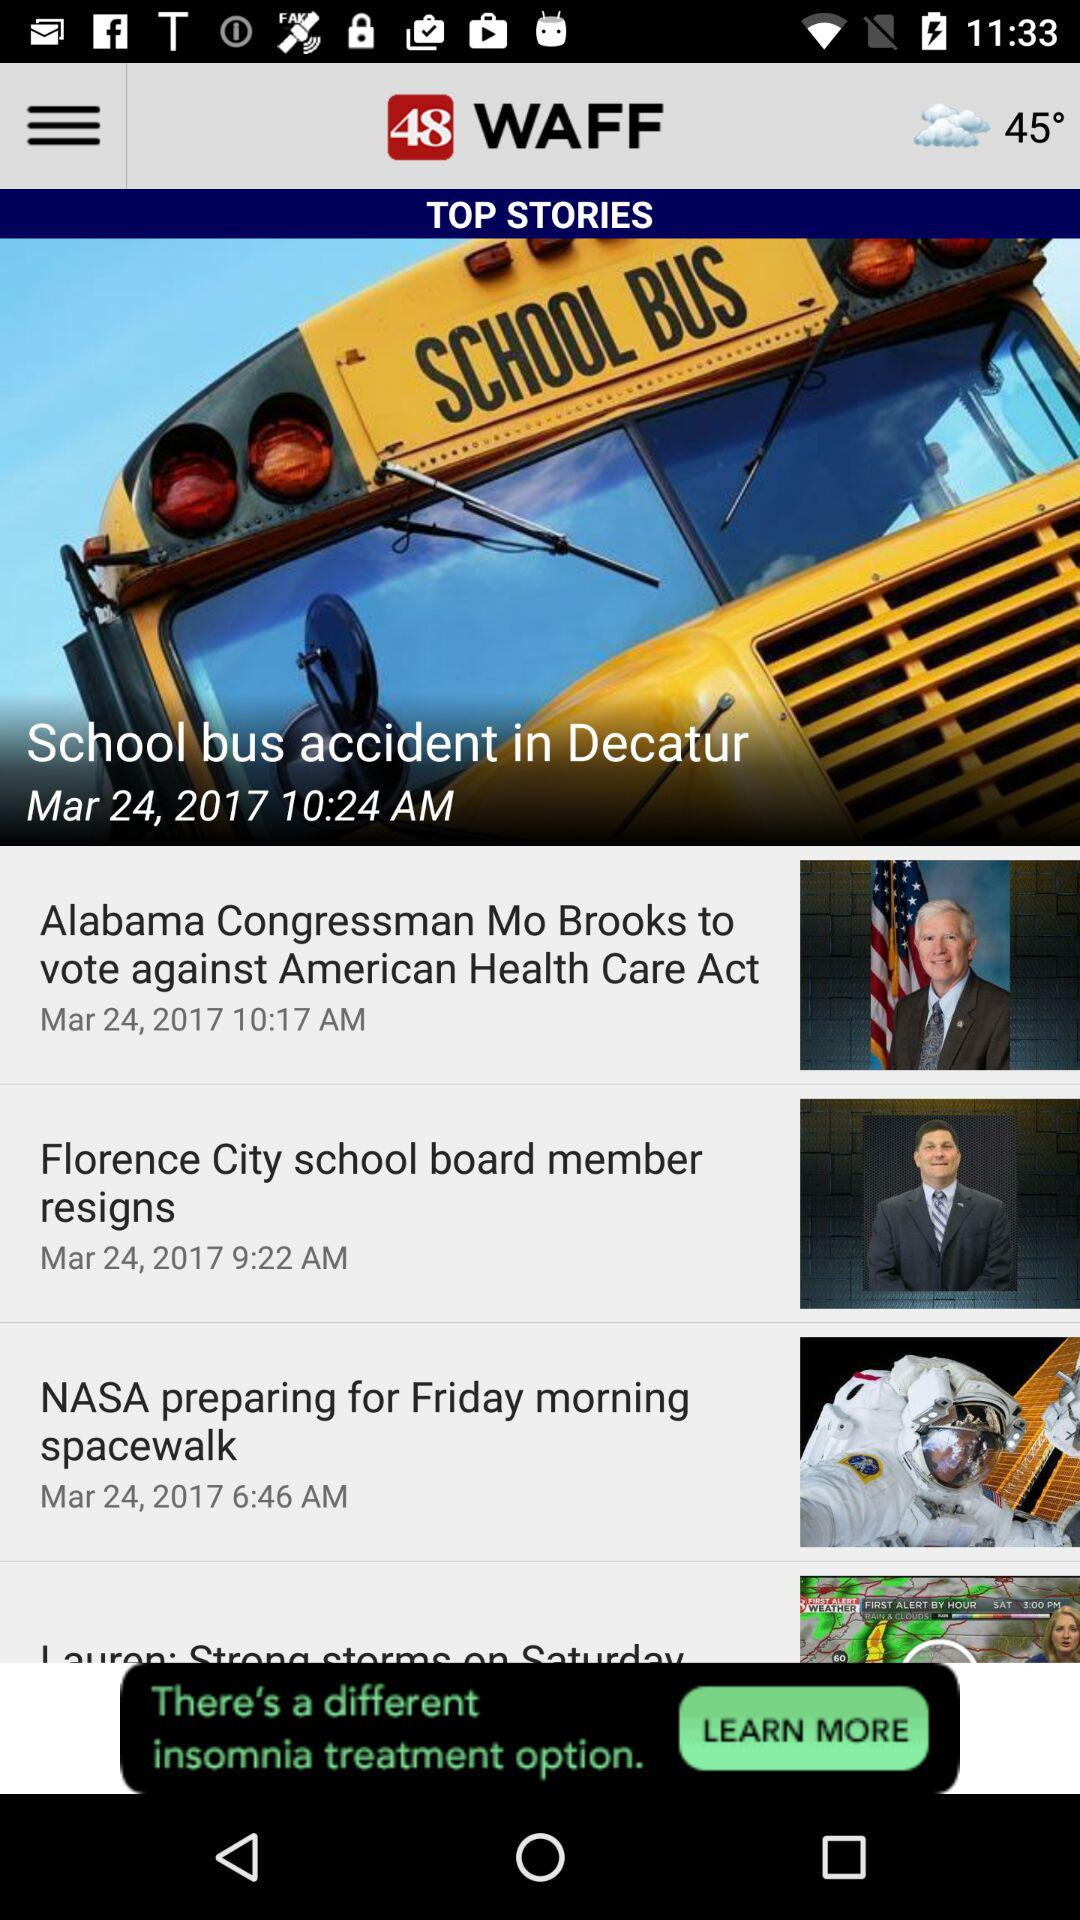What is the posted date and time of the "School bus accident in Decatur"? The posted date and time are March 24, 2017 and 10:24 AM, respectively. 